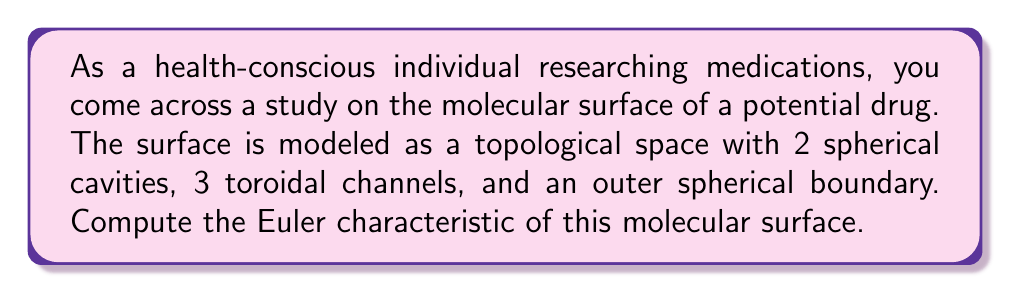Could you help me with this problem? To compute the Euler characteristic of this molecular surface, we'll use the following steps:

1) Recall the formula for Euler characteristic:
   $$\chi = V - E + F$$
   where $V$ is the number of vertices, $E$ is the number of edges, and $F$ is the number of faces.

2) For a sphere, $\chi = 2$. For a torus, $\chi = 0$.

3) The molecular surface consists of:
   - An outer spherical boundary ($\chi = 2$)
   - 2 spherical cavities (each with $\chi = 2$)
   - 3 toroidal channels (each with $\chi = 0$)

4) We can use the additivity property of Euler characteristic:
   $$\chi(\text{A} \cup \text{B}) = \chi(\text{A}) + \chi(\text{B}) - \chi(\text{A} \cap \text{B})$$

5) In this case, the intersections between components are negligible, so we can simply sum the Euler characteristics:

   $$\chi_{\text{total}} = \chi_{\text{outer sphere}} + \chi_{\text{cavities}} + \chi_{\text{channels}}$$
   
   $$\chi_{\text{total}} = 2 + (2 \times 2) + (3 \times 0)$$

6) Calculating:
   $$\chi_{\text{total}} = 2 + 4 + 0 = 6$$

Therefore, the Euler characteristic of the molecular surface is 6.
Answer: $6$ 